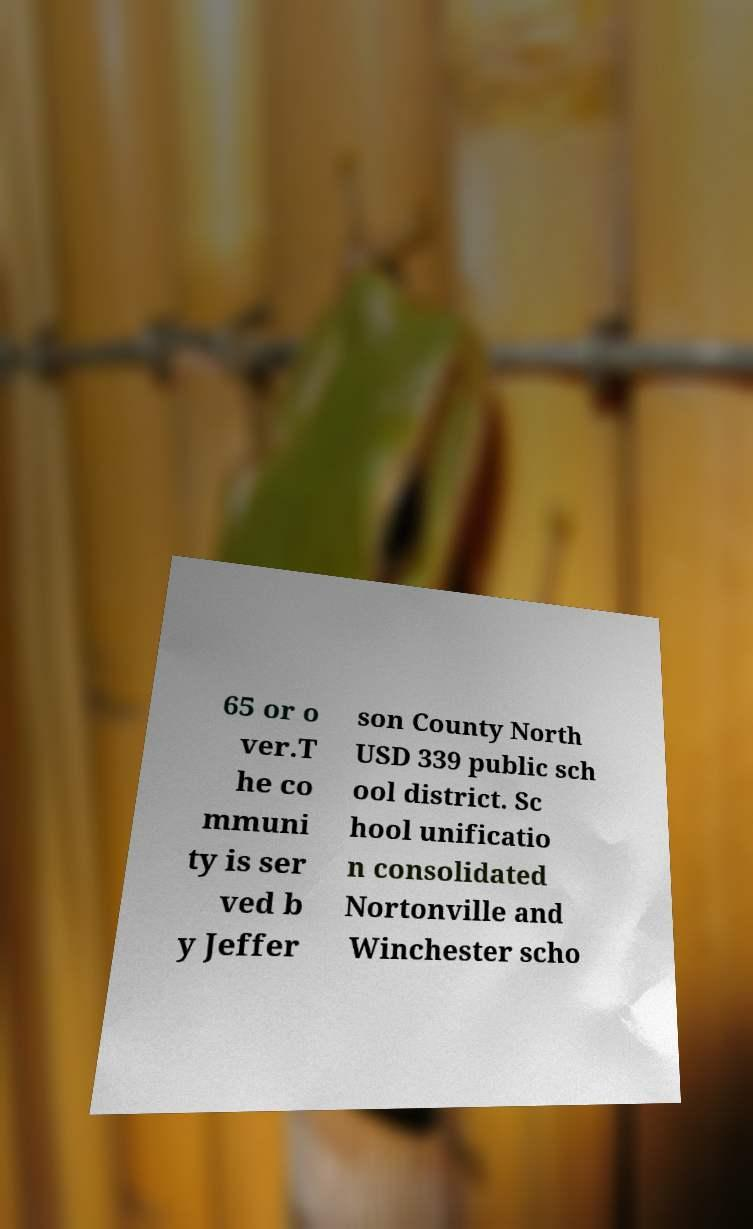I need the written content from this picture converted into text. Can you do that? 65 or o ver.T he co mmuni ty is ser ved b y Jeffer son County North USD 339 public sch ool district. Sc hool unificatio n consolidated Nortonville and Winchester scho 